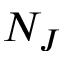<formula> <loc_0><loc_0><loc_500><loc_500>N _ { J }</formula> 